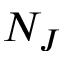<formula> <loc_0><loc_0><loc_500><loc_500>N _ { J }</formula> 